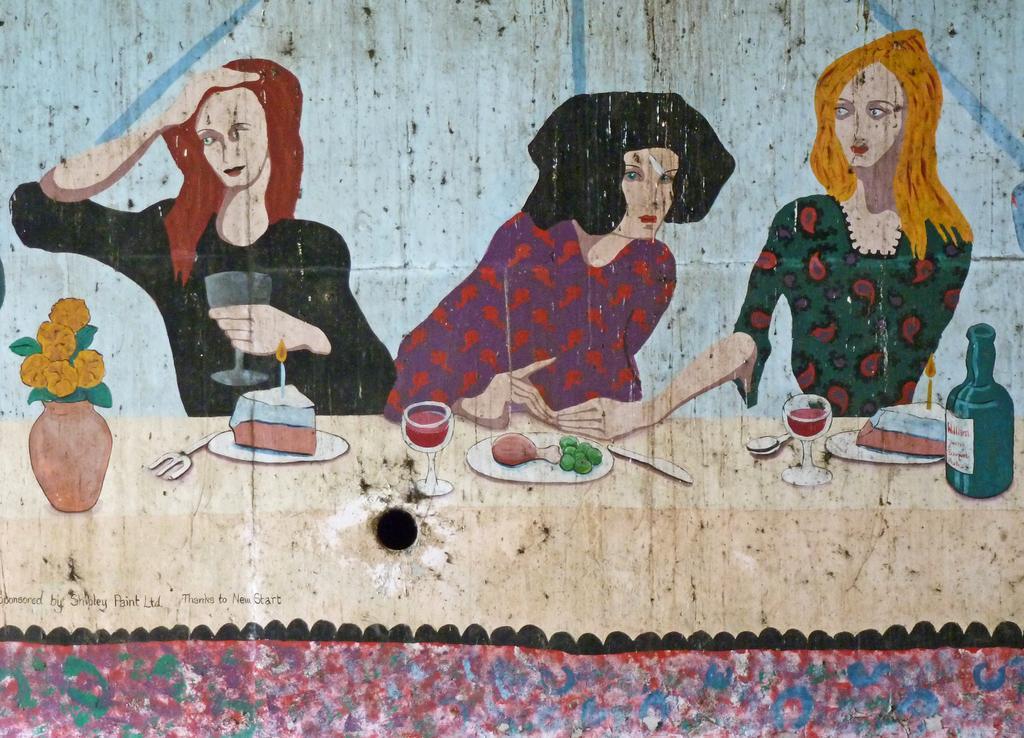How would you summarize this image in a sentence or two? This is a painting and here we can see people standing and one of them is holding a glass and here we can see a flower vase, plate, glass with liquid and food items are on the table. 